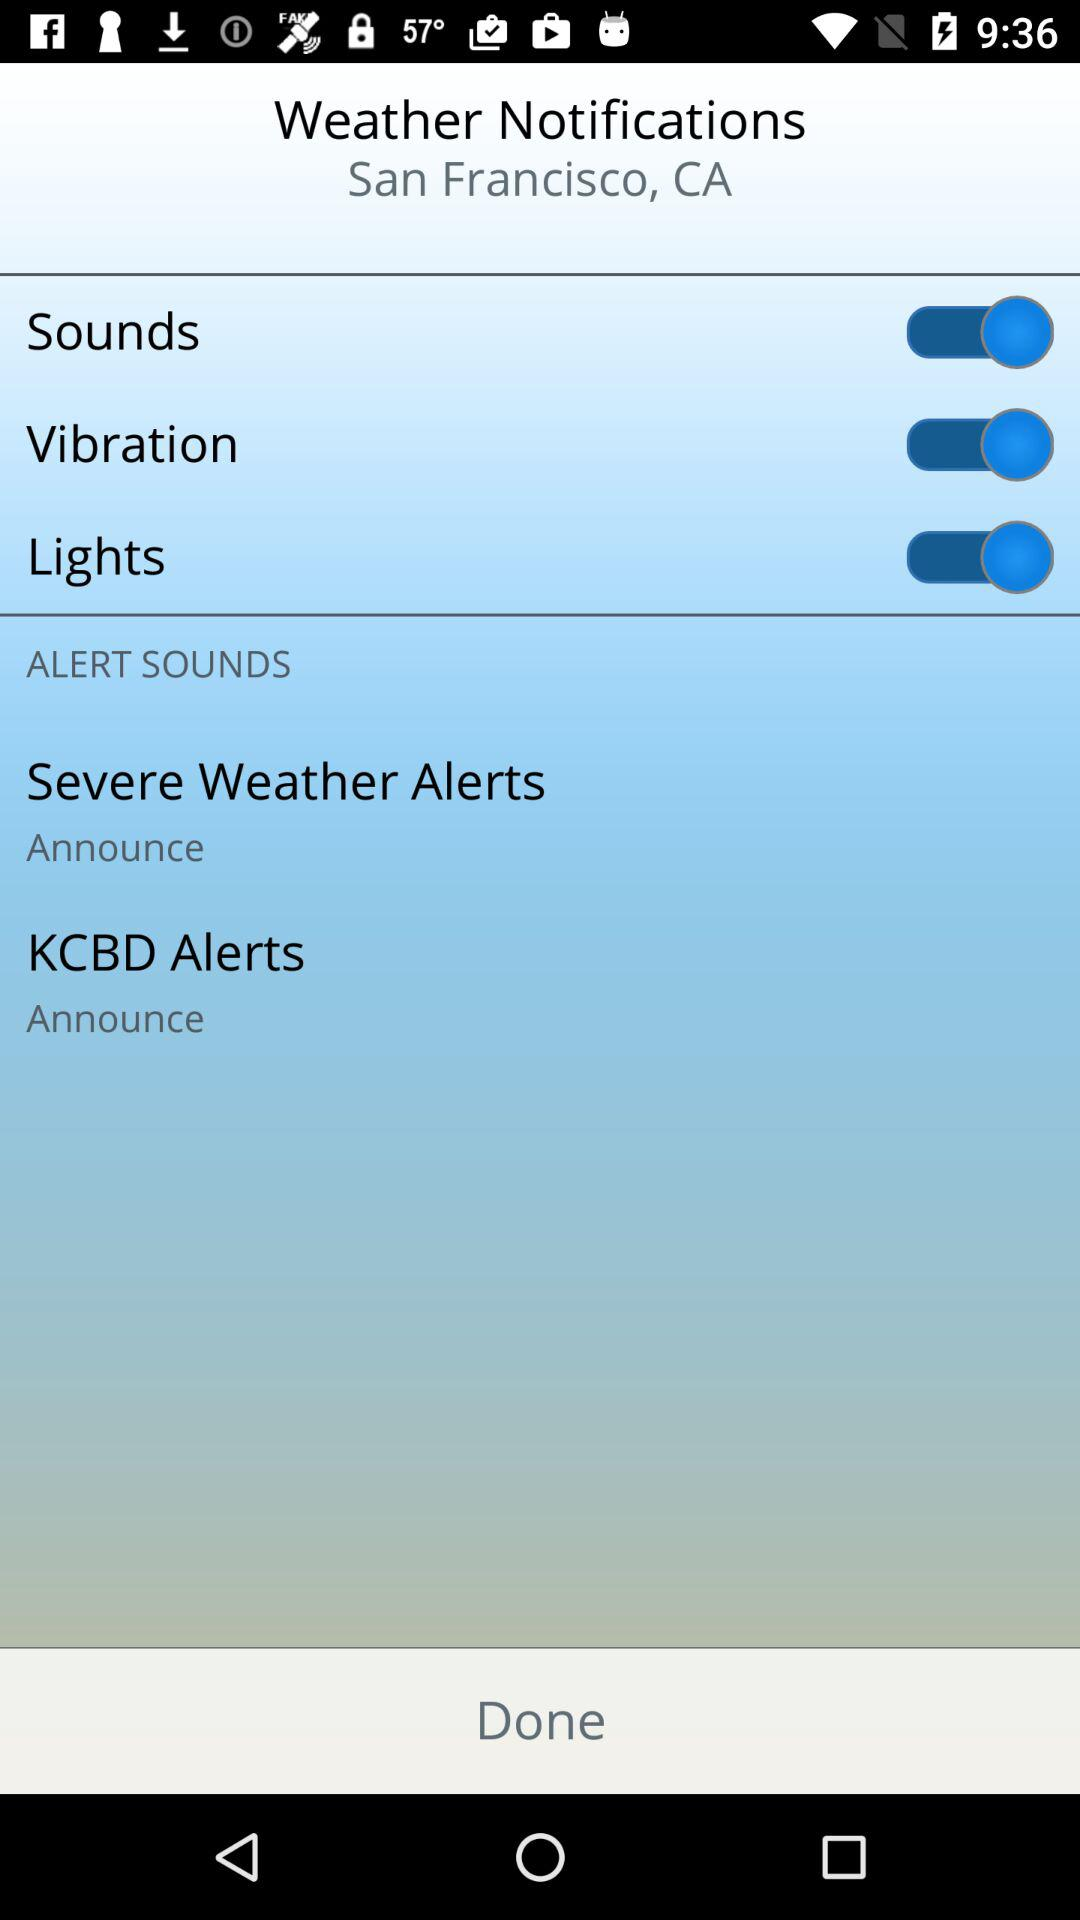How many alerts are there?
Answer the question using a single word or phrase. 2 